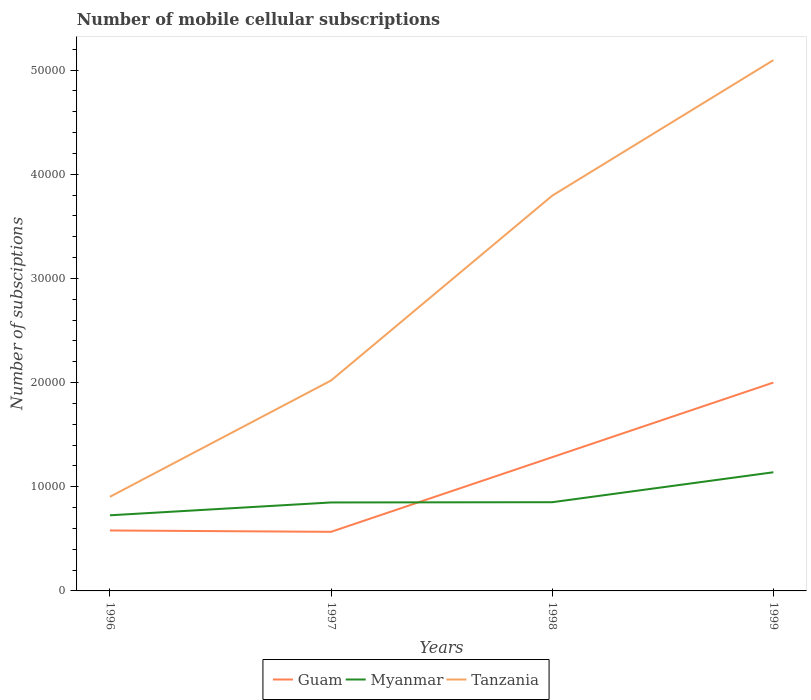Does the line corresponding to Myanmar intersect with the line corresponding to Tanzania?
Ensure brevity in your answer.  No. Is the number of lines equal to the number of legend labels?
Keep it short and to the point. Yes. Across all years, what is the maximum number of mobile cellular subscriptions in Tanzania?
Provide a short and direct response. 9038. In which year was the number of mobile cellular subscriptions in Myanmar maximum?
Give a very brief answer. 1996. What is the total number of mobile cellular subscriptions in Tanzania in the graph?
Provide a succinct answer. -3.08e+04. What is the difference between the highest and the second highest number of mobile cellular subscriptions in Myanmar?
Offer a very short reply. 4129. Is the number of mobile cellular subscriptions in Tanzania strictly greater than the number of mobile cellular subscriptions in Guam over the years?
Provide a short and direct response. No. How many years are there in the graph?
Your response must be concise. 4. What is the difference between two consecutive major ticks on the Y-axis?
Provide a succinct answer. 10000. Are the values on the major ticks of Y-axis written in scientific E-notation?
Your answer should be compact. No. Does the graph contain any zero values?
Make the answer very short. No. Does the graph contain grids?
Your response must be concise. No. Where does the legend appear in the graph?
Your answer should be compact. Bottom center. How many legend labels are there?
Keep it short and to the point. 3. What is the title of the graph?
Your answer should be very brief. Number of mobile cellular subscriptions. What is the label or title of the Y-axis?
Offer a very short reply. Number of subsciptions. What is the Number of subsciptions of Guam in 1996?
Your response must be concise. 5803. What is the Number of subsciptions of Myanmar in 1996?
Your answer should be very brief. 7260. What is the Number of subsciptions in Tanzania in 1996?
Your answer should be compact. 9038. What is the Number of subsciptions of Guam in 1997?
Provide a short and direct response. 5673. What is the Number of subsciptions of Myanmar in 1997?
Your response must be concise. 8492. What is the Number of subsciptions in Tanzania in 1997?
Make the answer very short. 2.02e+04. What is the Number of subsciptions in Guam in 1998?
Your answer should be very brief. 1.28e+04. What is the Number of subsciptions in Myanmar in 1998?
Give a very brief answer. 8516. What is the Number of subsciptions of Tanzania in 1998?
Your answer should be compact. 3.79e+04. What is the Number of subsciptions in Guam in 1999?
Make the answer very short. 2.00e+04. What is the Number of subsciptions of Myanmar in 1999?
Keep it short and to the point. 1.14e+04. What is the Number of subsciptions in Tanzania in 1999?
Offer a terse response. 5.10e+04. Across all years, what is the maximum Number of subsciptions of Guam?
Ensure brevity in your answer.  2.00e+04. Across all years, what is the maximum Number of subsciptions in Myanmar?
Offer a very short reply. 1.14e+04. Across all years, what is the maximum Number of subsciptions of Tanzania?
Offer a very short reply. 5.10e+04. Across all years, what is the minimum Number of subsciptions in Guam?
Keep it short and to the point. 5673. Across all years, what is the minimum Number of subsciptions in Myanmar?
Ensure brevity in your answer.  7260. Across all years, what is the minimum Number of subsciptions in Tanzania?
Your response must be concise. 9038. What is the total Number of subsciptions of Guam in the graph?
Make the answer very short. 4.43e+04. What is the total Number of subsciptions in Myanmar in the graph?
Your answer should be very brief. 3.57e+04. What is the total Number of subsciptions in Tanzania in the graph?
Provide a short and direct response. 1.18e+05. What is the difference between the Number of subsciptions of Guam in 1996 and that in 1997?
Provide a succinct answer. 130. What is the difference between the Number of subsciptions of Myanmar in 1996 and that in 1997?
Offer a terse response. -1232. What is the difference between the Number of subsciptions of Tanzania in 1996 and that in 1997?
Your answer should be compact. -1.12e+04. What is the difference between the Number of subsciptions of Guam in 1996 and that in 1998?
Make the answer very short. -7034. What is the difference between the Number of subsciptions of Myanmar in 1996 and that in 1998?
Your response must be concise. -1256. What is the difference between the Number of subsciptions in Tanzania in 1996 and that in 1998?
Your answer should be very brief. -2.89e+04. What is the difference between the Number of subsciptions of Guam in 1996 and that in 1999?
Your answer should be very brief. -1.42e+04. What is the difference between the Number of subsciptions in Myanmar in 1996 and that in 1999?
Your response must be concise. -4129. What is the difference between the Number of subsciptions in Tanzania in 1996 and that in 1999?
Ensure brevity in your answer.  -4.19e+04. What is the difference between the Number of subsciptions in Guam in 1997 and that in 1998?
Give a very brief answer. -7164. What is the difference between the Number of subsciptions of Myanmar in 1997 and that in 1998?
Make the answer very short. -24. What is the difference between the Number of subsciptions of Tanzania in 1997 and that in 1998?
Your answer should be compact. -1.77e+04. What is the difference between the Number of subsciptions in Guam in 1997 and that in 1999?
Offer a terse response. -1.43e+04. What is the difference between the Number of subsciptions in Myanmar in 1997 and that in 1999?
Give a very brief answer. -2897. What is the difference between the Number of subsciptions of Tanzania in 1997 and that in 1999?
Offer a very short reply. -3.08e+04. What is the difference between the Number of subsciptions in Guam in 1998 and that in 1999?
Ensure brevity in your answer.  -7163. What is the difference between the Number of subsciptions of Myanmar in 1998 and that in 1999?
Your answer should be very brief. -2873. What is the difference between the Number of subsciptions in Tanzania in 1998 and that in 1999?
Keep it short and to the point. -1.30e+04. What is the difference between the Number of subsciptions in Guam in 1996 and the Number of subsciptions in Myanmar in 1997?
Your response must be concise. -2689. What is the difference between the Number of subsciptions of Guam in 1996 and the Number of subsciptions of Tanzania in 1997?
Provide a short and direct response. -1.44e+04. What is the difference between the Number of subsciptions of Myanmar in 1996 and the Number of subsciptions of Tanzania in 1997?
Give a very brief answer. -1.29e+04. What is the difference between the Number of subsciptions in Guam in 1996 and the Number of subsciptions in Myanmar in 1998?
Ensure brevity in your answer.  -2713. What is the difference between the Number of subsciptions in Guam in 1996 and the Number of subsciptions in Tanzania in 1998?
Give a very brief answer. -3.21e+04. What is the difference between the Number of subsciptions of Myanmar in 1996 and the Number of subsciptions of Tanzania in 1998?
Offer a terse response. -3.07e+04. What is the difference between the Number of subsciptions of Guam in 1996 and the Number of subsciptions of Myanmar in 1999?
Your response must be concise. -5586. What is the difference between the Number of subsciptions of Guam in 1996 and the Number of subsciptions of Tanzania in 1999?
Ensure brevity in your answer.  -4.51e+04. What is the difference between the Number of subsciptions in Myanmar in 1996 and the Number of subsciptions in Tanzania in 1999?
Offer a terse response. -4.37e+04. What is the difference between the Number of subsciptions in Guam in 1997 and the Number of subsciptions in Myanmar in 1998?
Offer a terse response. -2843. What is the difference between the Number of subsciptions in Guam in 1997 and the Number of subsciptions in Tanzania in 1998?
Give a very brief answer. -3.23e+04. What is the difference between the Number of subsciptions of Myanmar in 1997 and the Number of subsciptions of Tanzania in 1998?
Your answer should be compact. -2.94e+04. What is the difference between the Number of subsciptions of Guam in 1997 and the Number of subsciptions of Myanmar in 1999?
Offer a terse response. -5716. What is the difference between the Number of subsciptions of Guam in 1997 and the Number of subsciptions of Tanzania in 1999?
Offer a very short reply. -4.53e+04. What is the difference between the Number of subsciptions in Myanmar in 1997 and the Number of subsciptions in Tanzania in 1999?
Give a very brief answer. -4.25e+04. What is the difference between the Number of subsciptions of Guam in 1998 and the Number of subsciptions of Myanmar in 1999?
Your answer should be compact. 1448. What is the difference between the Number of subsciptions of Guam in 1998 and the Number of subsciptions of Tanzania in 1999?
Your response must be concise. -3.81e+04. What is the difference between the Number of subsciptions of Myanmar in 1998 and the Number of subsciptions of Tanzania in 1999?
Keep it short and to the point. -4.24e+04. What is the average Number of subsciptions in Guam per year?
Make the answer very short. 1.11e+04. What is the average Number of subsciptions in Myanmar per year?
Provide a succinct answer. 8914.25. What is the average Number of subsciptions in Tanzania per year?
Provide a short and direct response. 2.95e+04. In the year 1996, what is the difference between the Number of subsciptions in Guam and Number of subsciptions in Myanmar?
Provide a succinct answer. -1457. In the year 1996, what is the difference between the Number of subsciptions of Guam and Number of subsciptions of Tanzania?
Offer a very short reply. -3235. In the year 1996, what is the difference between the Number of subsciptions in Myanmar and Number of subsciptions in Tanzania?
Offer a terse response. -1778. In the year 1997, what is the difference between the Number of subsciptions in Guam and Number of subsciptions in Myanmar?
Keep it short and to the point. -2819. In the year 1997, what is the difference between the Number of subsciptions in Guam and Number of subsciptions in Tanzania?
Make the answer very short. -1.45e+04. In the year 1997, what is the difference between the Number of subsciptions of Myanmar and Number of subsciptions of Tanzania?
Offer a terse response. -1.17e+04. In the year 1998, what is the difference between the Number of subsciptions in Guam and Number of subsciptions in Myanmar?
Make the answer very short. 4321. In the year 1998, what is the difference between the Number of subsciptions in Guam and Number of subsciptions in Tanzania?
Your response must be concise. -2.51e+04. In the year 1998, what is the difference between the Number of subsciptions in Myanmar and Number of subsciptions in Tanzania?
Your response must be concise. -2.94e+04. In the year 1999, what is the difference between the Number of subsciptions in Guam and Number of subsciptions in Myanmar?
Your response must be concise. 8611. In the year 1999, what is the difference between the Number of subsciptions of Guam and Number of subsciptions of Tanzania?
Your response must be concise. -3.10e+04. In the year 1999, what is the difference between the Number of subsciptions in Myanmar and Number of subsciptions in Tanzania?
Make the answer very short. -3.96e+04. What is the ratio of the Number of subsciptions of Guam in 1996 to that in 1997?
Provide a succinct answer. 1.02. What is the ratio of the Number of subsciptions in Myanmar in 1996 to that in 1997?
Keep it short and to the point. 0.85. What is the ratio of the Number of subsciptions in Tanzania in 1996 to that in 1997?
Make the answer very short. 0.45. What is the ratio of the Number of subsciptions in Guam in 1996 to that in 1998?
Ensure brevity in your answer.  0.45. What is the ratio of the Number of subsciptions in Myanmar in 1996 to that in 1998?
Make the answer very short. 0.85. What is the ratio of the Number of subsciptions of Tanzania in 1996 to that in 1998?
Your answer should be very brief. 0.24. What is the ratio of the Number of subsciptions of Guam in 1996 to that in 1999?
Give a very brief answer. 0.29. What is the ratio of the Number of subsciptions of Myanmar in 1996 to that in 1999?
Your answer should be very brief. 0.64. What is the ratio of the Number of subsciptions of Tanzania in 1996 to that in 1999?
Your response must be concise. 0.18. What is the ratio of the Number of subsciptions in Guam in 1997 to that in 1998?
Make the answer very short. 0.44. What is the ratio of the Number of subsciptions in Tanzania in 1997 to that in 1998?
Offer a terse response. 0.53. What is the ratio of the Number of subsciptions of Guam in 1997 to that in 1999?
Your answer should be compact. 0.28. What is the ratio of the Number of subsciptions in Myanmar in 1997 to that in 1999?
Give a very brief answer. 0.75. What is the ratio of the Number of subsciptions in Tanzania in 1997 to that in 1999?
Ensure brevity in your answer.  0.4. What is the ratio of the Number of subsciptions in Guam in 1998 to that in 1999?
Your answer should be very brief. 0.64. What is the ratio of the Number of subsciptions in Myanmar in 1998 to that in 1999?
Your response must be concise. 0.75. What is the ratio of the Number of subsciptions of Tanzania in 1998 to that in 1999?
Offer a very short reply. 0.74. What is the difference between the highest and the second highest Number of subsciptions of Guam?
Give a very brief answer. 7163. What is the difference between the highest and the second highest Number of subsciptions in Myanmar?
Offer a terse response. 2873. What is the difference between the highest and the second highest Number of subsciptions of Tanzania?
Your response must be concise. 1.30e+04. What is the difference between the highest and the lowest Number of subsciptions in Guam?
Provide a short and direct response. 1.43e+04. What is the difference between the highest and the lowest Number of subsciptions in Myanmar?
Your response must be concise. 4129. What is the difference between the highest and the lowest Number of subsciptions in Tanzania?
Provide a succinct answer. 4.19e+04. 